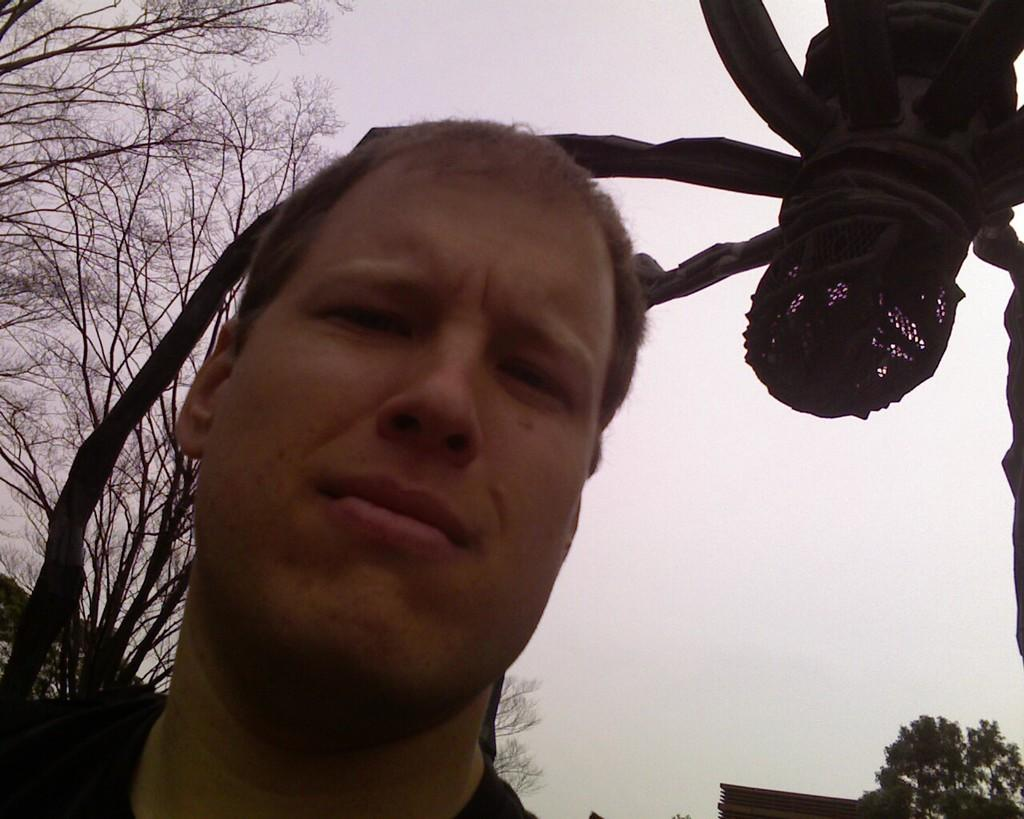Who is present in the image? There is a man in the picture. What can be seen in the background of the image? There are trees and the sky visible in the background of the picture. Are there any other objects or features in the background of the image? Yes, there are other objects in the background of the picture. Can you see any dinosaurs in the image? No, there are no dinosaurs present in the image. How does the man pull the trees in the background? The man is not pulling any trees in the image; there are no actions or interactions depicted between the man and the trees. 